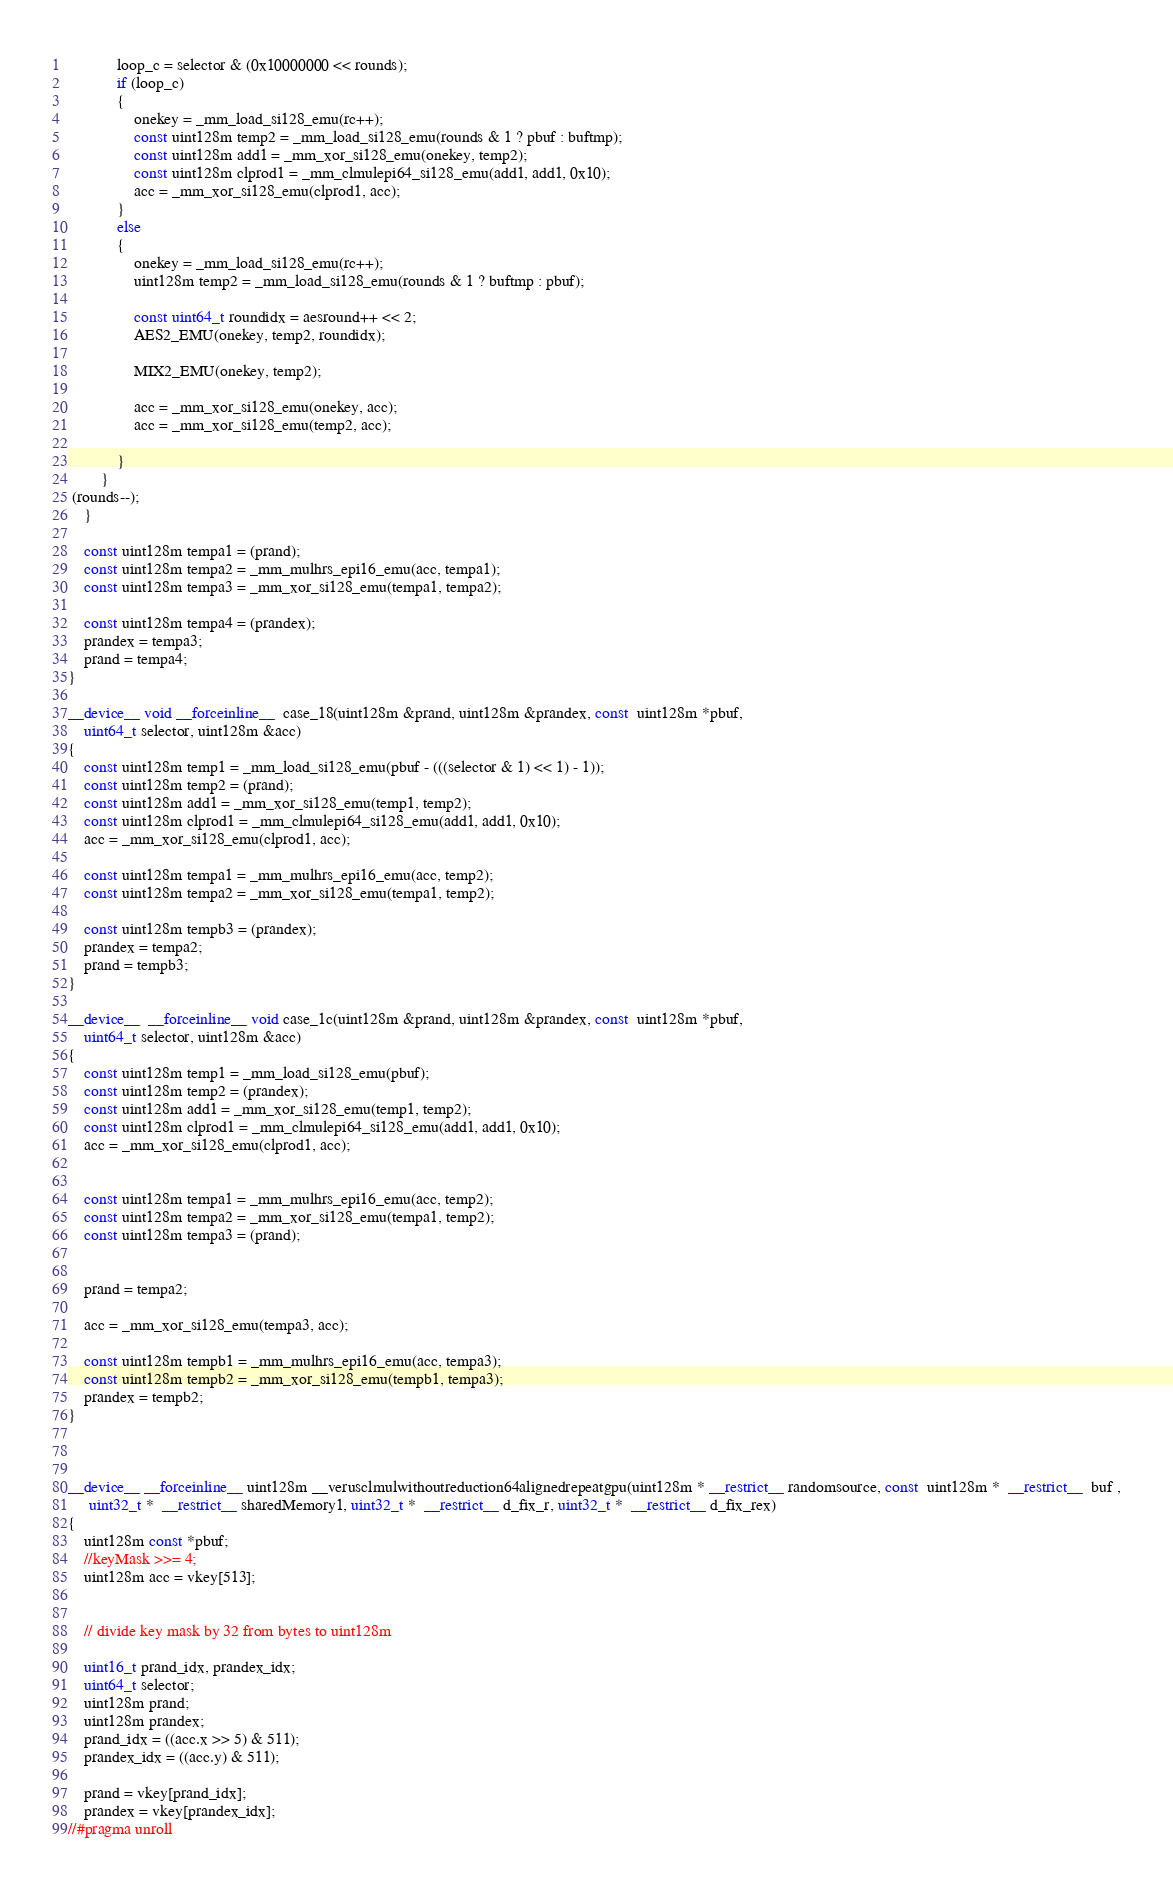Convert code to text. <code><loc_0><loc_0><loc_500><loc_500><_Cuda_>			loop_c = selector & (0x10000000 << rounds);
			if (loop_c)
			{
				onekey = _mm_load_si128_emu(rc++);
				const uint128m temp2 = _mm_load_si128_emu(rounds & 1 ? pbuf : buftmp);
				const uint128m add1 = _mm_xor_si128_emu(onekey, temp2);
				const uint128m clprod1 = _mm_clmulepi64_si128_emu(add1, add1, 0x10);
				acc = _mm_xor_si128_emu(clprod1, acc);
			}
			else
			{
				onekey = _mm_load_si128_emu(rc++);
				uint128m temp2 = _mm_load_si128_emu(rounds & 1 ? buftmp : pbuf);

				const uint64_t roundidx = aesround++ << 2;
				AES2_EMU(onekey, temp2, roundidx);

				MIX2_EMU(onekey, temp2);

				acc = _mm_xor_si128_emu(onekey, acc);
				acc = _mm_xor_si128_emu(temp2, acc);

			}
		}
 (rounds--);
	} 

	const uint128m tempa1 = (prand);
	const uint128m tempa2 = _mm_mulhrs_epi16_emu(acc, tempa1);
	const uint128m tempa3 = _mm_xor_si128_emu(tempa1, tempa2);

	const uint128m tempa4 = (prandex);
	prandex = tempa3;
	prand = tempa4;
}

__device__ void __forceinline__  case_18(uint128m &prand, uint128m &prandex, const  uint128m *pbuf,
	uint64_t selector, uint128m &acc)
{
	const uint128m temp1 = _mm_load_si128_emu(pbuf - (((selector & 1) << 1) - 1));
	const uint128m temp2 = (prand);
	const uint128m add1 = _mm_xor_si128_emu(temp1, temp2);
	const uint128m clprod1 = _mm_clmulepi64_si128_emu(add1, add1, 0x10);
	acc = _mm_xor_si128_emu(clprod1, acc);

	const uint128m tempa1 = _mm_mulhrs_epi16_emu(acc, temp2);
	const uint128m tempa2 = _mm_xor_si128_emu(tempa1, temp2);

	const uint128m tempb3 = (prandex);
	prandex = tempa2;
	prand = tempb3;
}

__device__  __forceinline__ void case_1c(uint128m &prand, uint128m &prandex, const  uint128m *pbuf,
	uint64_t selector, uint128m &acc)
{
	const uint128m temp1 = _mm_load_si128_emu(pbuf);
	const uint128m temp2 = (prandex);
	const uint128m add1 = _mm_xor_si128_emu(temp1, temp2);
	const uint128m clprod1 = _mm_clmulepi64_si128_emu(add1, add1, 0x10);
	acc = _mm_xor_si128_emu(clprod1, acc);


	const uint128m tempa1 = _mm_mulhrs_epi16_emu(acc, temp2);
	const uint128m tempa2 = _mm_xor_si128_emu(tempa1, temp2);
	const uint128m tempa3 = (prand);


	prand = tempa2;

	acc = _mm_xor_si128_emu(tempa3, acc);

	const uint128m tempb1 = _mm_mulhrs_epi16_emu(acc, tempa3);
	const uint128m tempb2 = _mm_xor_si128_emu(tempb1, tempa3);
	prandex = tempb2;
}



__device__ __forceinline__ uint128m __verusclmulwithoutreduction64alignedrepeatgpu(uint128m * __restrict__ randomsource, const  uint128m *  __restrict__  buf ,
	 uint32_t *  __restrict__ sharedMemory1, uint32_t *  __restrict__ d_fix_r, uint32_t *  __restrict__ d_fix_rex)
{
    uint128m const *pbuf;
	//keyMask >>= 4;
	uint128m acc = vkey[513];
	
	
	// divide key mask by 32 from bytes to uint128m
	
	uint16_t prand_idx, prandex_idx;
	uint64_t selector;
	uint128m prand;
	uint128m prandex;
	prand_idx = ((acc.x >> 5) & 511);
	prandex_idx = ((acc.y) & 511);

	prand = vkey[prand_idx];
	prandex = vkey[prandex_idx];
//#pragma unroll</code> 